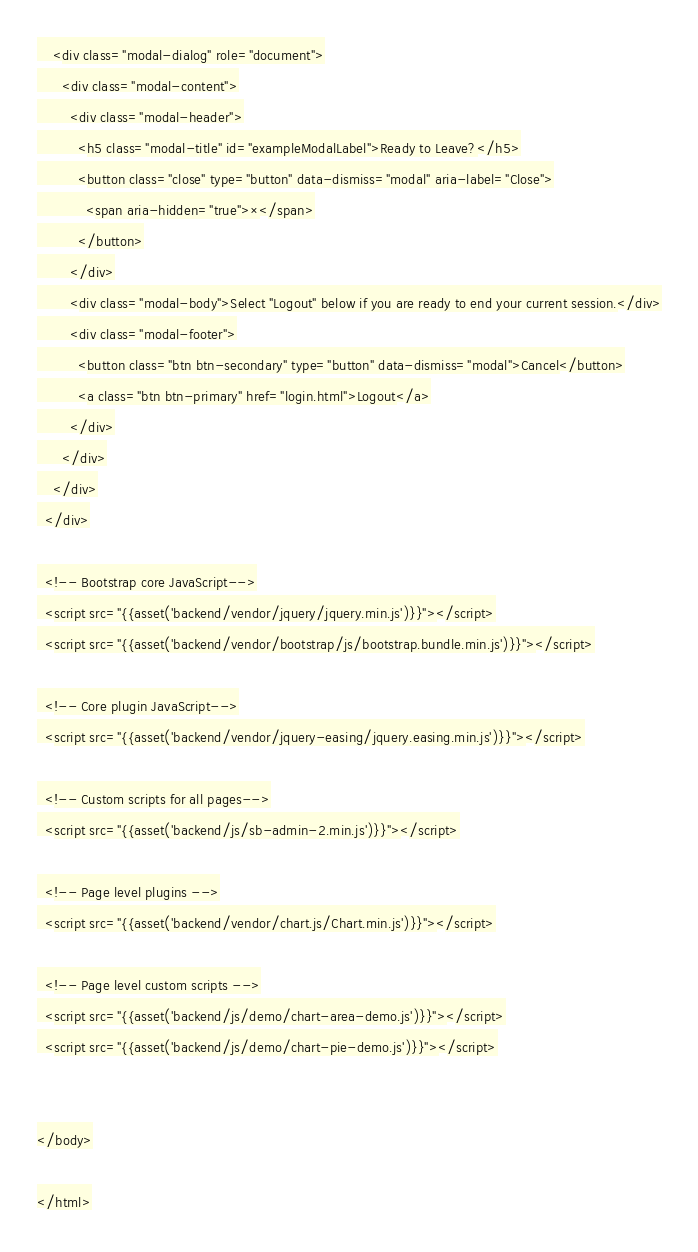Convert code to text. <code><loc_0><loc_0><loc_500><loc_500><_PHP_>    <div class="modal-dialog" role="document">
      <div class="modal-content">
        <div class="modal-header">
          <h5 class="modal-title" id="exampleModalLabel">Ready to Leave?</h5>
          <button class="close" type="button" data-dismiss="modal" aria-label="Close">
            <span aria-hidden="true">×</span>
          </button>
        </div>
        <div class="modal-body">Select "Logout" below if you are ready to end your current session.</div>
        <div class="modal-footer">
          <button class="btn btn-secondary" type="button" data-dismiss="modal">Cancel</button>
          <a class="btn btn-primary" href="login.html">Logout</a>
        </div>
      </div>
    </div>
  </div>

  <!-- Bootstrap core JavaScript-->
  <script src="{{asset('backend/vendor/jquery/jquery.min.js')}}"></script>
  <script src="{{asset('backend/vendor/bootstrap/js/bootstrap.bundle.min.js')}}"></script>

  <!-- Core plugin JavaScript-->
  <script src="{{asset('backend/vendor/jquery-easing/jquery.easing.min.js')}}"></script>

  <!-- Custom scripts for all pages-->
  <script src="{{asset('backend/js/sb-admin-2.min.js')}}"></script>

  <!-- Page level plugins -->
  <script src="{{asset('backend/vendor/chart.js/Chart.min.js')}}"></script>

  <!-- Page level custom scripts -->
  <script src="{{asset('backend/js/demo/chart-area-demo.js')}}"></script>
  <script src="{{asset('backend/js/demo/chart-pie-demo.js')}}"></script>


</body>

</html>
</code> 